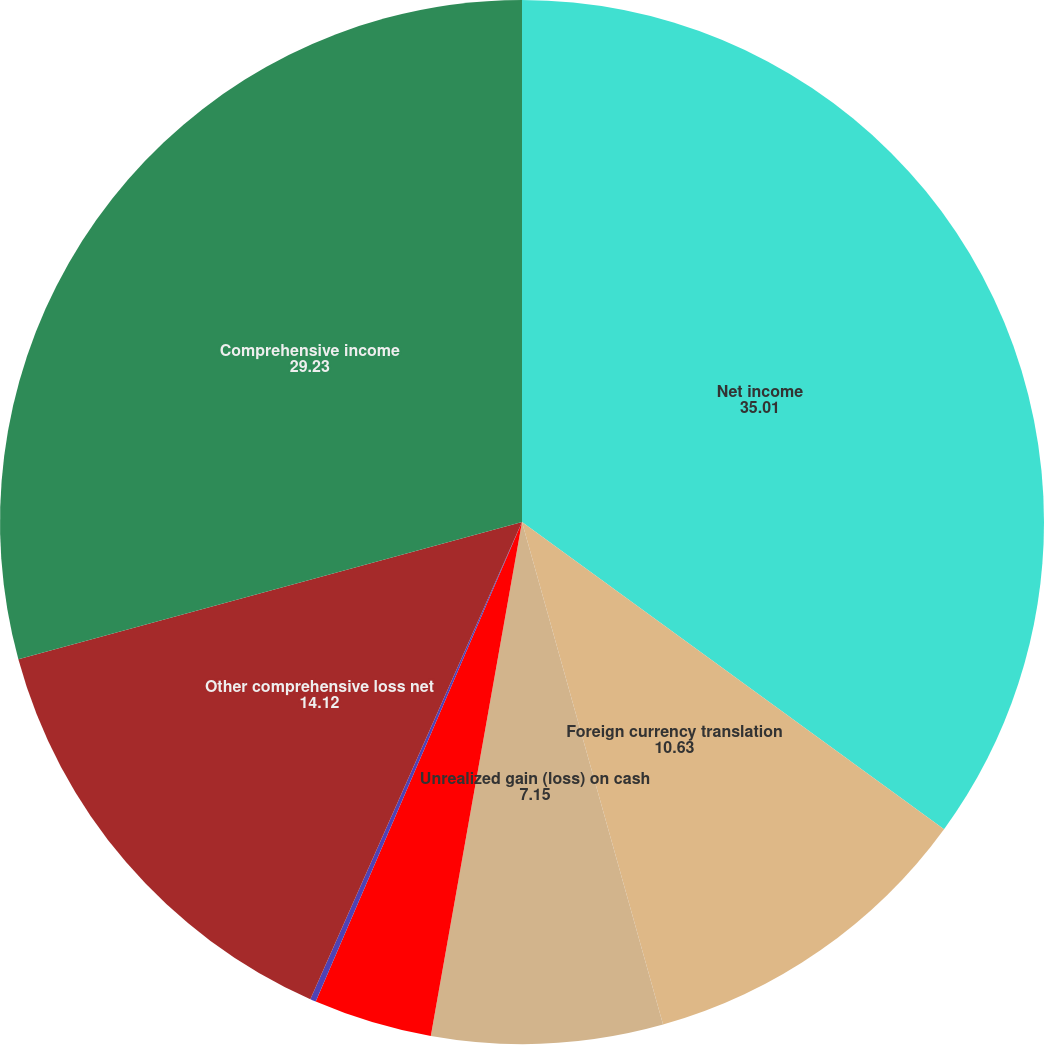Convert chart to OTSL. <chart><loc_0><loc_0><loc_500><loc_500><pie_chart><fcel>Net income<fcel>Foreign currency translation<fcel>Unrealized gain (loss) on cash<fcel>Defined benefit pension<fcel>Unrealized gain (loss) on<fcel>Other comprehensive loss net<fcel>Comprehensive income<nl><fcel>35.01%<fcel>10.63%<fcel>7.15%<fcel>3.67%<fcel>0.18%<fcel>14.12%<fcel>29.23%<nl></chart> 